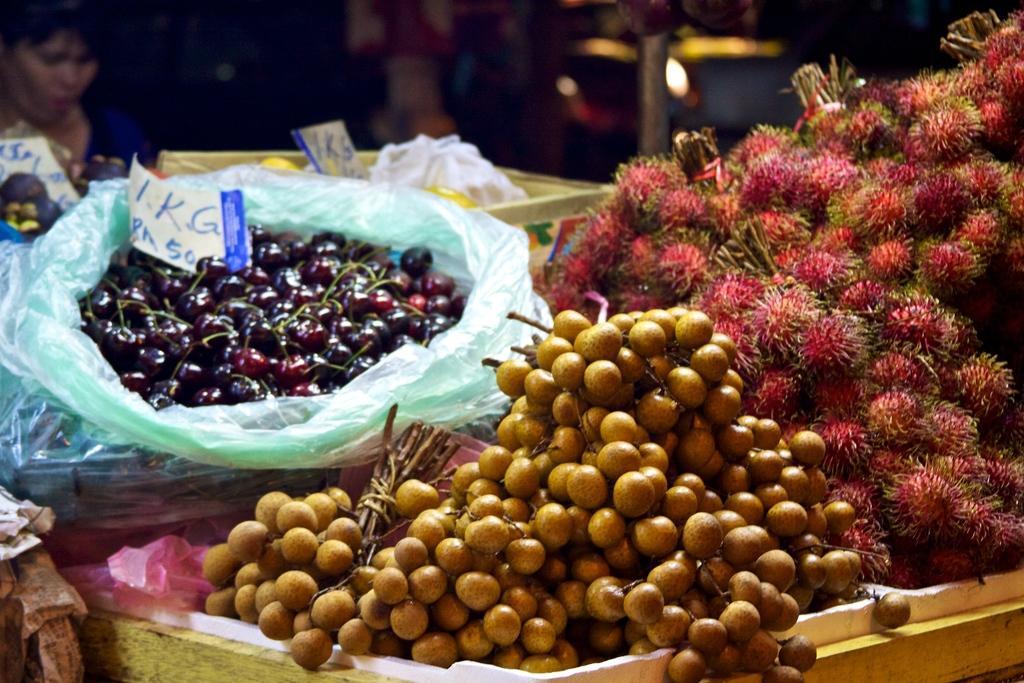Please provide a concise description of this image. In this picture I can see some fruits, flowers are kept on the table and a woman sitting in front of the table. 